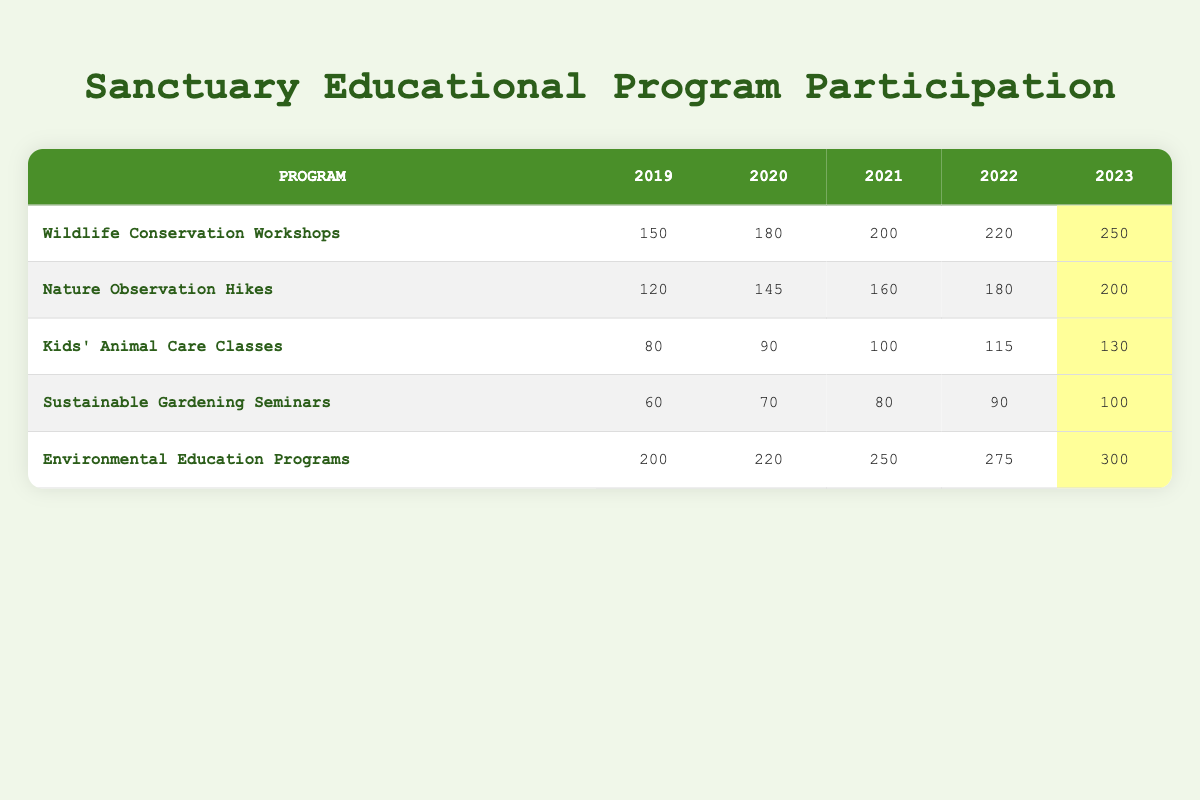What was the number of participants in the Wildlife Conservation Workshops in 2023? The table shows that for the Wildlife Conservation Workshops, the number of participants listed for the year 2023 is 250.
Answer: 250 What was the total number of participants across all programs in 2022? To find the total participants in 2022, we add the participants from each program: 220 (Wildlife Conservation Workshops) + 180 (Nature Observation Hikes) + 115 (Kids' Animal Care Classes) + 90 (Sustainable Gardening Seminars) + 275 (Environmental Education Programs) = 880.
Answer: 880 Did the number of participants in the Sustainable Gardening Seminars increase every year from 2019 to 2023? Looking at the numbers for Sustainable Gardening Seminars, they have increased from 60 in 2019 to 70 in 2020, 80 in 2021, 90 in 2022, and 100 in 2023, indicating a consistent increase each year.
Answer: Yes What was the percentage increase in participants for the Environmental Education Programs from 2019 to 2023? The number of participants in 2019 was 200 and in 2023 it was 300. The increase is 300 - 200 = 100. To find the percentage increase: (100 / 200) * 100% = 50%.
Answer: 50% Which program had the highest increase in participants from 2019 to 2023? By examining the participant increases: Wildlife Conservation Workshops gained 100, Nature Observation Hikes gained 80, Kids' Animal Care Classes gained 50, Sustainable Gardening Seminars gained 40, and Environmental Education Programs gained 100. The highest increase is tied between Wildlife Conservation Workshops and Environmental Education Programs, both with an increase of 100 participants.
Answer: Wildlife Conservation Workshops and Environmental Education Programs What is the average number of participants for Kids' Animal Care Classes over the last five years? To calculate the average, sum the participants: 80 + 90 + 100 + 115 + 130 = 515, and divide by the number of years (5): 515 / 5 = 103.
Answer: 103 Did Nature Observation Hikes have more participants than Kids' Animal Care Classes in 2021? In 2021, Nature Observation Hikes had 160 participants, whereas Kids' Animal Care Classes had 100 participants. Therefore, Nature Observation Hikes had more participants.
Answer: Yes Which year saw the least participation in Sustainable Gardening Seminars? The number of participants in Sustainable Gardening Seminars was 60 in 2019, which is the lowest compared to the following years (70, 80, 90, and 100 in subsequent years).
Answer: 2019 